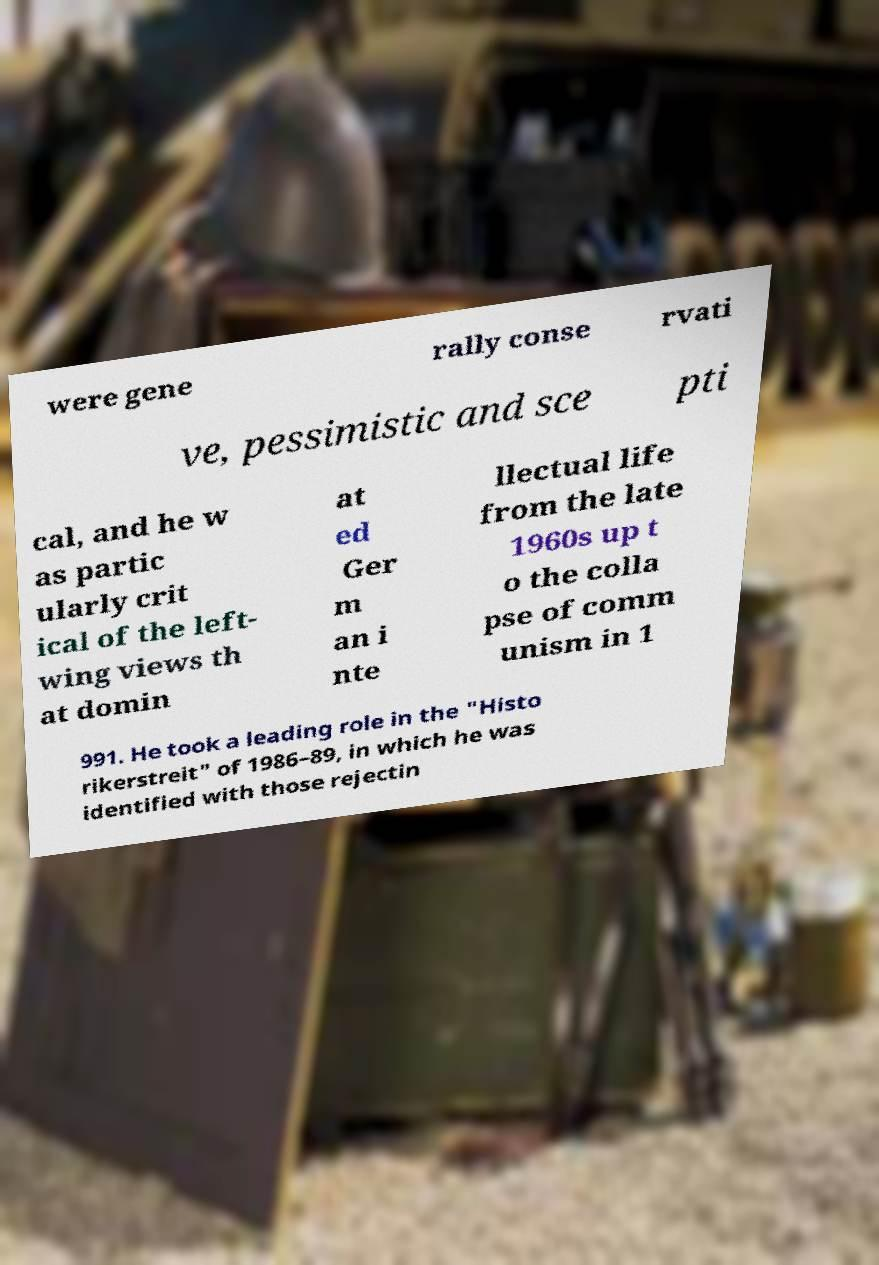What messages or text are displayed in this image? I need them in a readable, typed format. were gene rally conse rvati ve, pessimistic and sce pti cal, and he w as partic ularly crit ical of the left- wing views th at domin at ed Ger m an i nte llectual life from the late 1960s up t o the colla pse of comm unism in 1 991. He took a leading role in the "Histo rikerstreit" of 1986–89, in which he was identified with those rejectin 